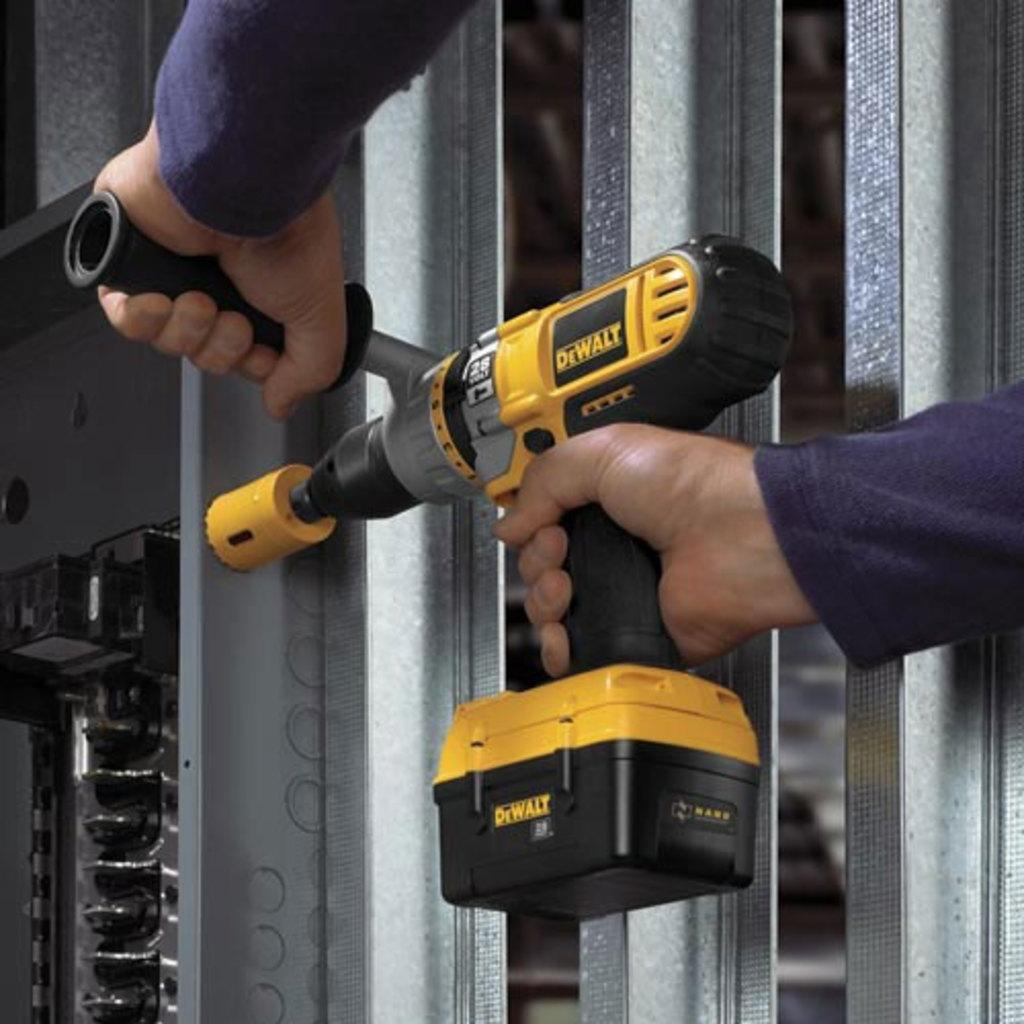What is the main subject of the image? There is a person in the image. What is the person holding in the image? The person is holding a yellow-colored hand drill. What type of trail is visible in the image? There is no trail visible in the image; it only features a person holding a yellow-colored hand drill. 